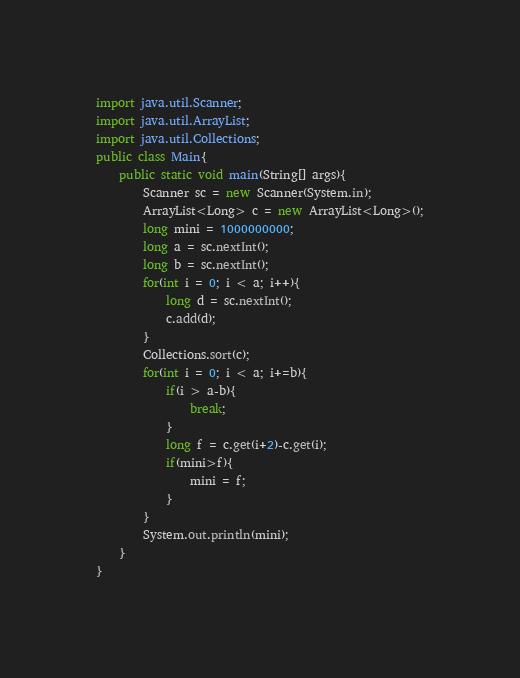Convert code to text. <code><loc_0><loc_0><loc_500><loc_500><_Java_>import java.util.Scanner;
import java.util.ArrayList;
import java.util.Collections;
public class Main{
	public static void main(String[] args){
		Scanner sc = new Scanner(System.in);
		ArrayList<Long> c = new ArrayList<Long>();
		long mini = 1000000000;
		long a = sc.nextInt();
		long b = sc.nextInt();
		for(int i = 0; i < a; i++){
			long d = sc.nextInt();
			c.add(d);
		}
		Collections.sort(c);
		for(int i = 0; i < a; i+=b){
			if(i > a-b){
				break;
			}
			long f = c.get(i+2)-c.get(i);
			if(mini>f){
				mini = f;
			}
		}
		System.out.println(mini);
	}
}</code> 